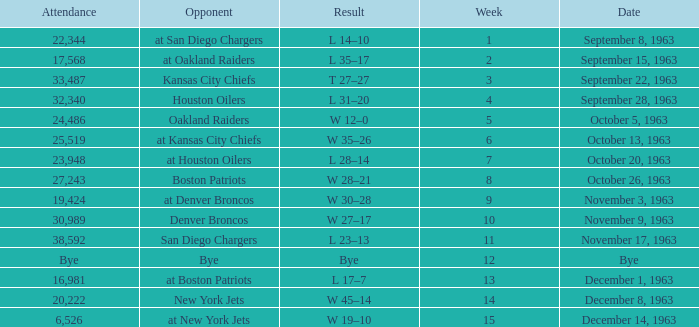In which match-up, does one of the opponents have a 14-10 result? At san diego chargers. 